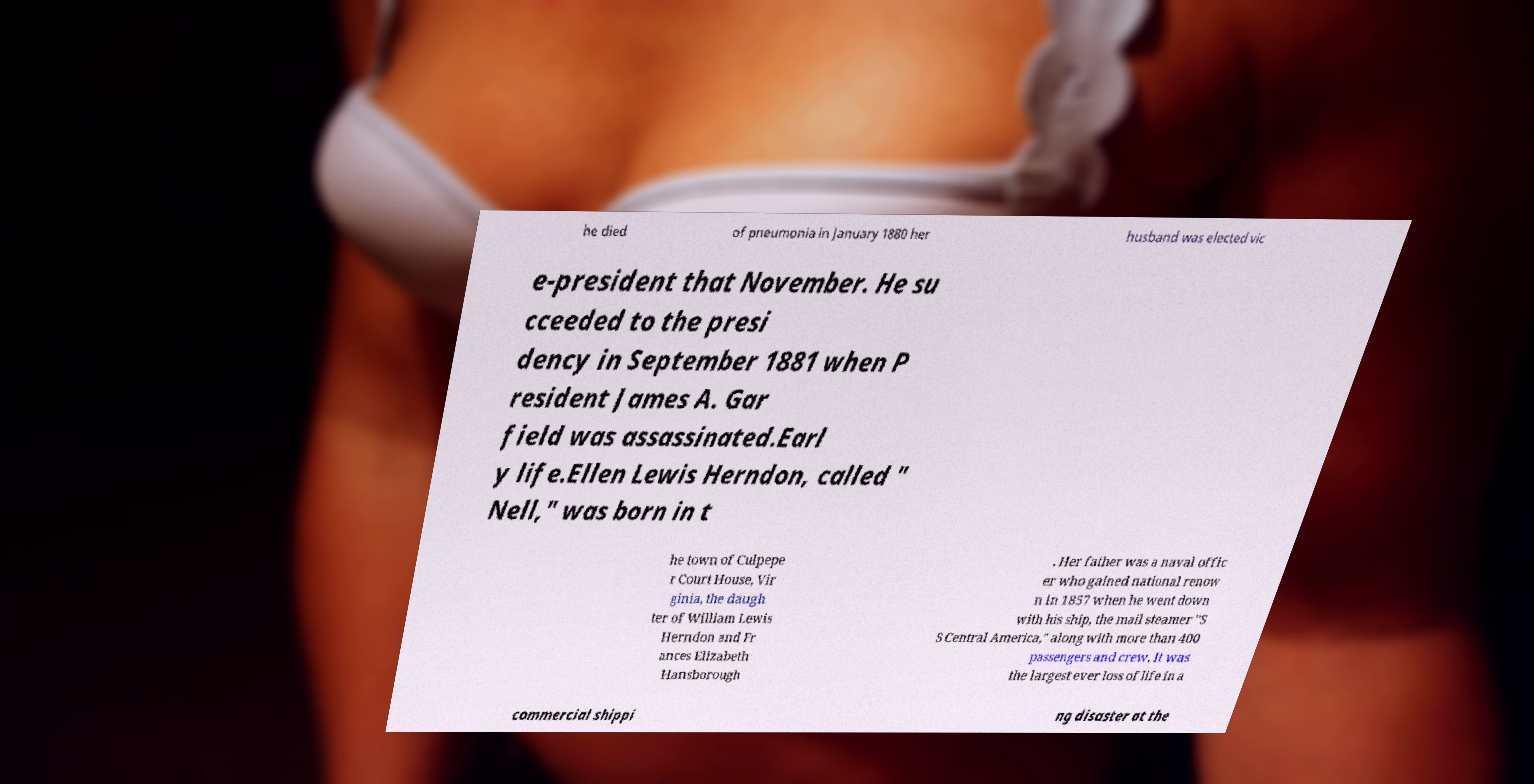I need the written content from this picture converted into text. Can you do that? he died of pneumonia in January 1880 her husband was elected vic e-president that November. He su cceeded to the presi dency in September 1881 when P resident James A. Gar field was assassinated.Earl y life.Ellen Lewis Herndon, called " Nell," was born in t he town of Culpepe r Court House, Vir ginia, the daugh ter of William Lewis Herndon and Fr ances Elizabeth Hansborough . Her father was a naval offic er who gained national renow n in 1857 when he went down with his ship, the mail steamer "S S Central America," along with more than 400 passengers and crew. It was the largest ever loss of life in a commercial shippi ng disaster at the 